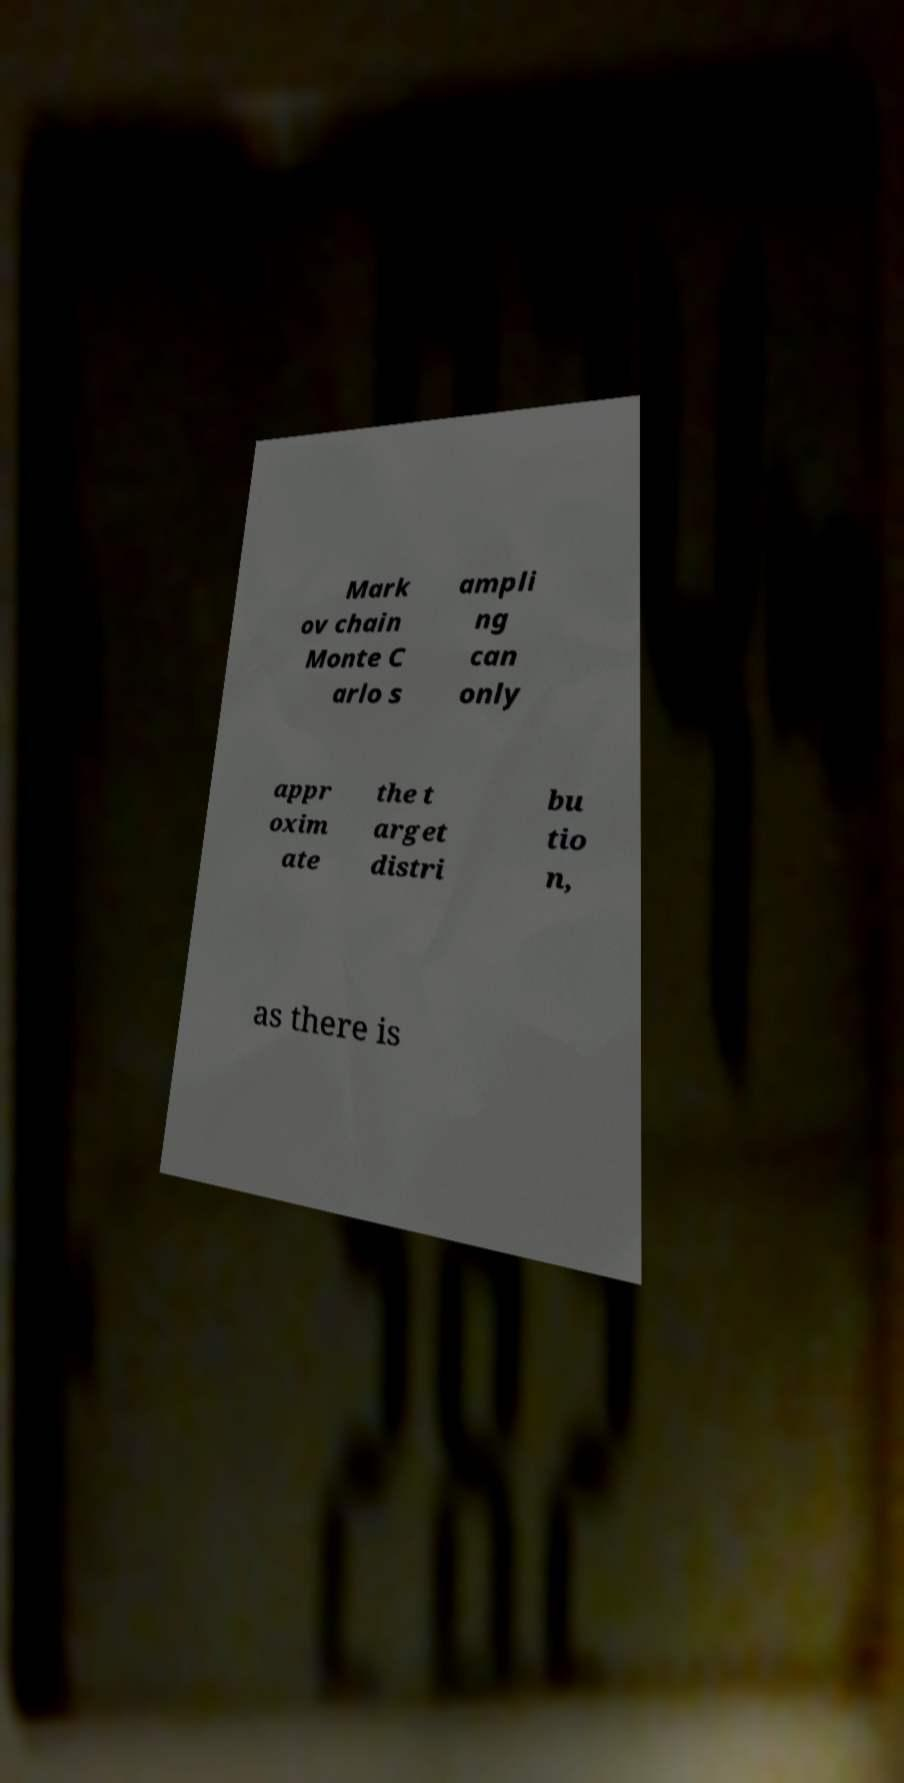Please identify and transcribe the text found in this image. Mark ov chain Monte C arlo s ampli ng can only appr oxim ate the t arget distri bu tio n, as there is 